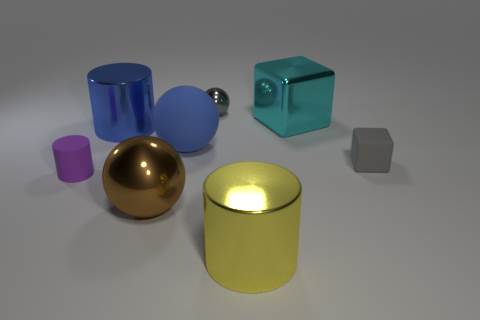The brown object that is the same size as the matte sphere is what shape?
Give a very brief answer. Sphere. There is a big sphere that is behind the purple matte object; what color is it?
Provide a succinct answer. Blue. How many objects are large metallic objects behind the gray matte block or things behind the blue shiny object?
Provide a succinct answer. 3. Do the yellow thing and the blue ball have the same size?
Make the answer very short. Yes. How many cubes are blue metallic things or big blue objects?
Provide a short and direct response. 0. How many objects are both in front of the blue matte ball and to the left of the large brown shiny ball?
Your response must be concise. 1. Is the size of the matte block the same as the metal cylinder in front of the purple cylinder?
Offer a terse response. No. There is a big metal object that is right of the big shiny cylinder that is in front of the gray cube; are there any blue shiny cylinders to the right of it?
Make the answer very short. No. The gray object that is left of the gray thing in front of the matte ball is made of what material?
Keep it short and to the point. Metal. What is the big object that is both in front of the big blue metal cylinder and behind the small purple rubber cylinder made of?
Keep it short and to the point. Rubber. 